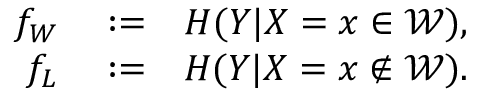Convert formula to latex. <formula><loc_0><loc_0><loc_500><loc_500>\begin{array} { r l r } { f _ { W } } & \colon = } & { H ( Y | X = x \in \mathcal { W } ) , } \\ { f _ { L } } & \colon = } & { H ( Y | X = x \notin \mathcal { W } ) . } \end{array}</formula> 